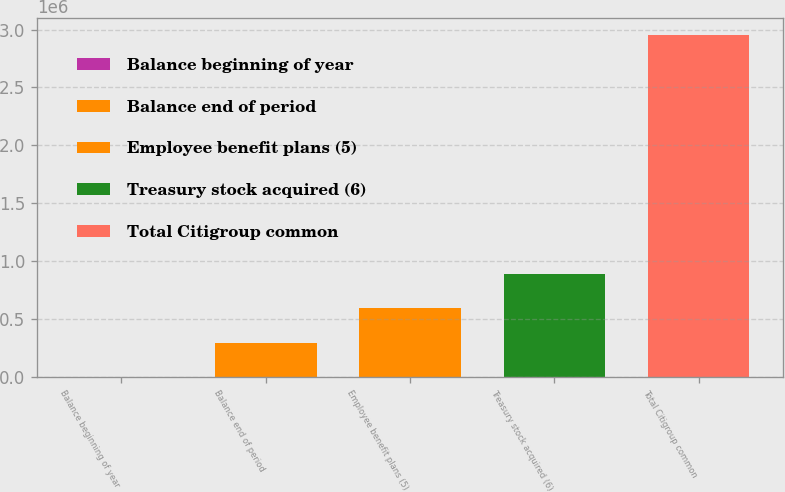<chart> <loc_0><loc_0><loc_500><loc_500><bar_chart><fcel>Balance beginning of year<fcel>Balance end of period<fcel>Employee benefit plans (5)<fcel>Treasury stock acquired (6)<fcel>Total Citigroup common<nl><fcel>419<fcel>295705<fcel>590991<fcel>886277<fcel>2.95328e+06<nl></chart> 